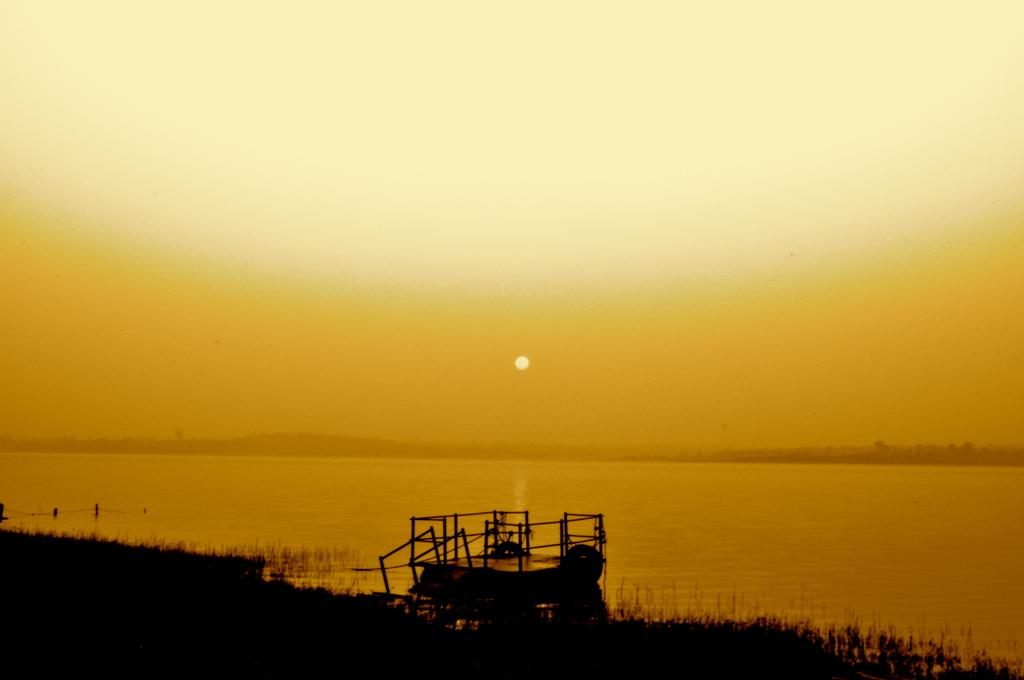What is on the water in the image? There is an object on the water in the image. What can be seen in the background of the image? There are trees and the sun visible in the background of the image. How many pennies can be seen floating near the object on the water? There are no pennies visible in the image; it only features an object on the water, trees, and the sun in the background. 